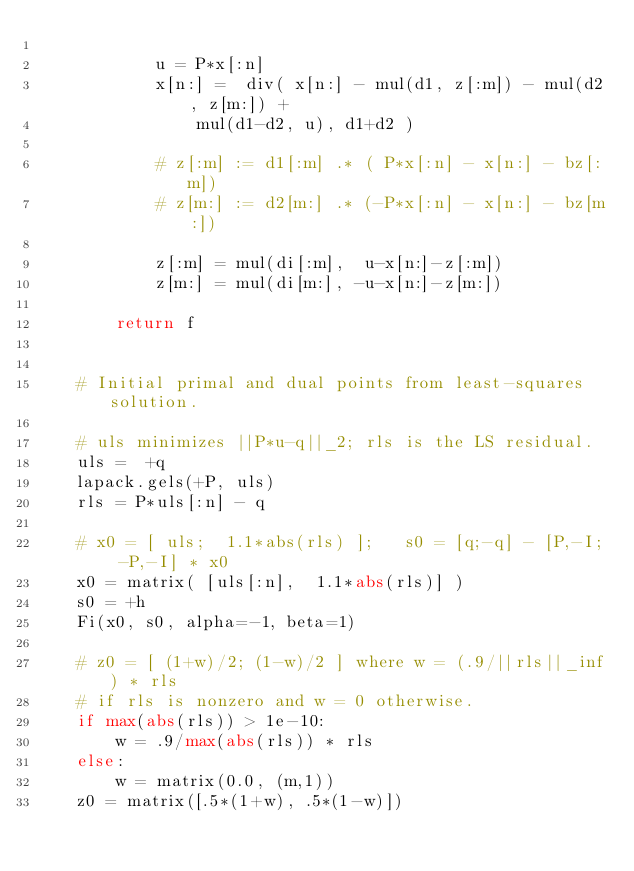Convert code to text. <code><loc_0><loc_0><loc_500><loc_500><_Python_>
            u = P*x[:n]
            x[n:] =  div( x[n:] - mul(d1, z[:m]) - mul(d2, z[m:]) + 
                mul(d1-d2, u), d1+d2 )

            # z[:m] := d1[:m] .* ( P*x[:n] - x[n:] - bz[:m])
            # z[m:] := d2[m:] .* (-P*x[:n] - x[n:] - bz[m:]) 

            z[:m] = mul(di[:m],  u-x[n:]-z[:m])
            z[m:] = mul(di[m:], -u-x[n:]-z[m:])

        return f


    # Initial primal and dual points from least-squares solution.

    # uls minimizes ||P*u-q||_2; rls is the LS residual.
    uls =  +q
    lapack.gels(+P, uls)
    rls = P*uls[:n] - q 

    # x0 = [ uls;  1.1*abs(rls) ];   s0 = [q;-q] - [P,-I; -P,-I] * x0
    x0 = matrix( [uls[:n],  1.1*abs(rls)] ) 
    s0 = +h
    Fi(x0, s0, alpha=-1, beta=1) 

    # z0 = [ (1+w)/2; (1-w)/2 ] where w = (.9/||rls||_inf) * rls  
    # if rls is nonzero and w = 0 otherwise.
    if max(abs(rls)) > 1e-10:  
        w = .9/max(abs(rls)) * rls
    else: 
        w = matrix(0.0, (m,1))
    z0 = matrix([.5*(1+w), .5*(1-w)])
</code> 